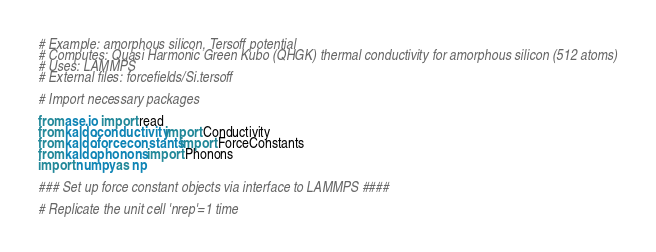Convert code to text. <code><loc_0><loc_0><loc_500><loc_500><_Python_># Example: amorphous silicon, Tersoff potential 
# Computes: Quasi Harmonic Green Kubo (QHGK) thermal conductivity for amorphous silicon (512 atoms)
# Uses: LAMMPS
# External files: forcefields/Si.tersoff

# Import necessary packages

from ase.io import read
from kaldo.conductivity import Conductivity
from kaldo.forceconstants import ForceConstants
from kaldo.phonons import Phonons
import numpy as np

### Set up force constant objects via interface to LAMMPS ####

# Replicate the unit cell 'nrep'=1 time</code> 